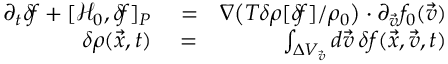Convert formula to latex. <formula><loc_0><loc_0><loc_500><loc_500>\begin{array} { r l r } { \partial _ { t } \delta \, f + [ \mathcal { H } _ { 0 } , \delta \, f ] _ { P } } & = } & { \nabla \left ( T \delta \rho [ \delta \, f ] / \rho _ { 0 } \right ) \cdot \partial _ { \vec { v } } f _ { 0 } ( \vec { v } ) } \\ { \delta \rho ( \vec { x } , t ) } & = } & { \int _ { \Delta V _ { \vec { v } } } d \vec { v } \, \delta f ( \vec { x } , \vec { v } , t ) } \end{array}</formula> 